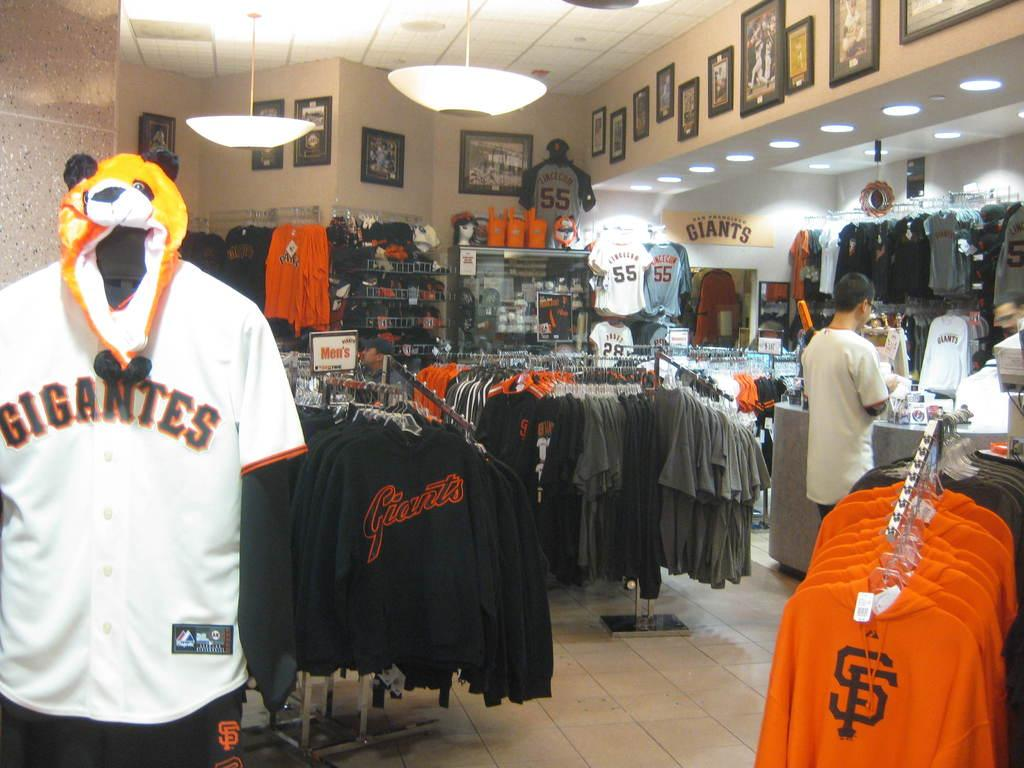<image>
Give a short and clear explanation of the subsequent image. A Gigantes jersey is on a mannequin in the store along with a bear hat. 